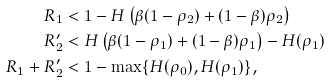<formula> <loc_0><loc_0><loc_500><loc_500>R _ { 1 } & < 1 - H \left ( \beta ( 1 - \rho _ { 2 } ) + ( 1 - \beta ) \rho _ { 2 } \right ) \\ R _ { 2 } ^ { \prime } & < H \left ( \beta ( 1 - \rho _ { 1 } ) + ( 1 - \beta ) \rho _ { 1 } \right ) - H ( \rho _ { 1 } ) \\ R _ { 1 } + R _ { 2 } ^ { \prime } & < 1 - \max \{ H ( \rho _ { 0 } ) , H ( \rho _ { 1 } ) \} ,</formula> 